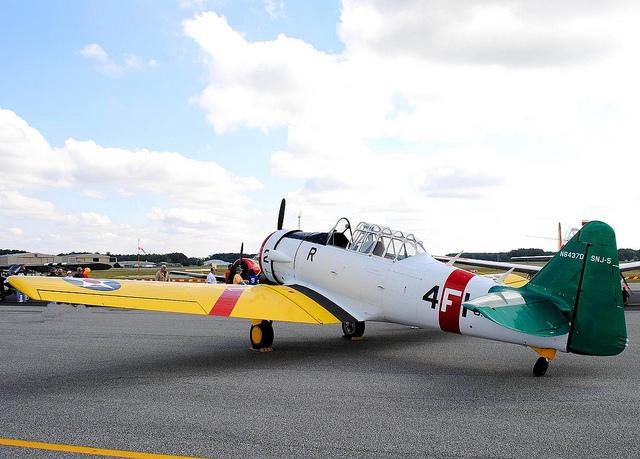What is the number covered in red?
Keep it brief. F. Is it a good day for flying?
Concise answer only. Yes. What color is the left wing on this small plane?
Short answer required. Yellow. 